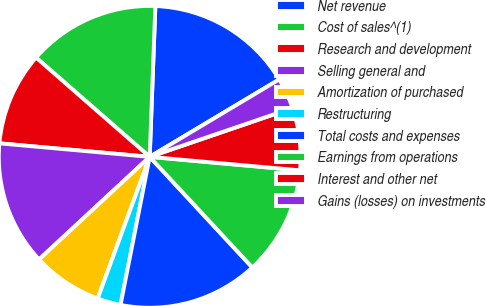Convert chart to OTSL. <chart><loc_0><loc_0><loc_500><loc_500><pie_chart><fcel>Net revenue<fcel>Cost of sales^(1)<fcel>Research and development<fcel>Selling general and<fcel>Amortization of purchased<fcel>Restructuring<fcel>Total costs and expenses<fcel>Earnings from operations<fcel>Interest and other net<fcel>Gains (losses) on investments<nl><fcel>15.83%<fcel>14.17%<fcel>10.0%<fcel>13.33%<fcel>7.5%<fcel>2.5%<fcel>15.0%<fcel>11.67%<fcel>6.67%<fcel>3.33%<nl></chart> 